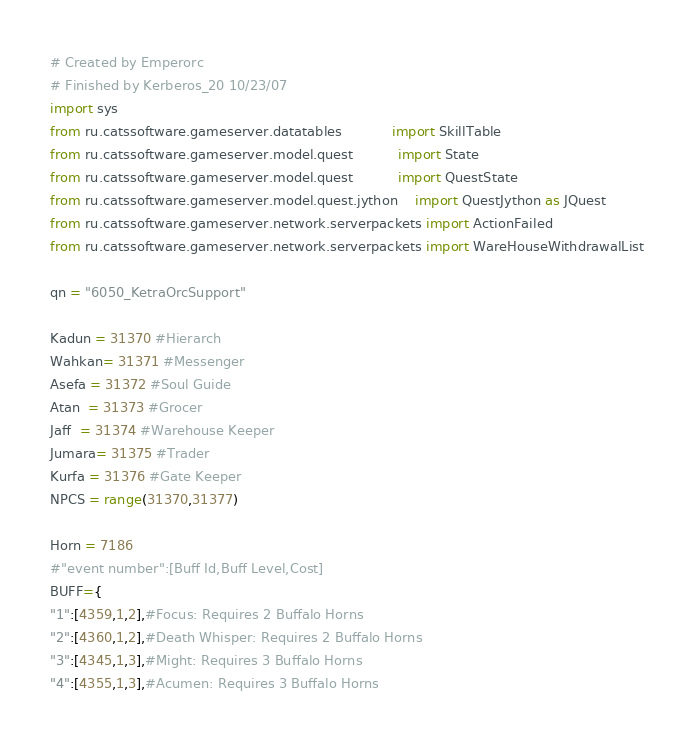<code> <loc_0><loc_0><loc_500><loc_500><_Python_># Created by Emperorc
# Finished by Kerberos_20 10/23/07
import sys
from ru.catssoftware.gameserver.datatables            import SkillTable
from ru.catssoftware.gameserver.model.quest           import State
from ru.catssoftware.gameserver.model.quest           import QuestState
from ru.catssoftware.gameserver.model.quest.jython    import QuestJython as JQuest
from ru.catssoftware.gameserver.network.serverpackets import ActionFailed
from ru.catssoftware.gameserver.network.serverpackets import WareHouseWithdrawalList

qn = "6050_KetraOrcSupport"

Kadun = 31370 #Hierarch
Wahkan= 31371 #Messenger
Asefa = 31372 #Soul Guide
Atan  = 31373 #Grocer
Jaff  = 31374 #Warehouse Keeper
Jumara= 31375 #Trader
Kurfa = 31376 #Gate Keeper
NPCS = range(31370,31377)

Horn = 7186
#"event number":[Buff Id,Buff Level,Cost]
BUFF={
"1":[4359,1,2],#Focus: Requires 2 Buffalo Horns
"2":[4360,1,2],#Death Whisper: Requires 2 Buffalo Horns
"3":[4345,1,3],#Might: Requires 3 Buffalo Horns
"4":[4355,1,3],#Acumen: Requires 3 Buffalo Horns</code> 